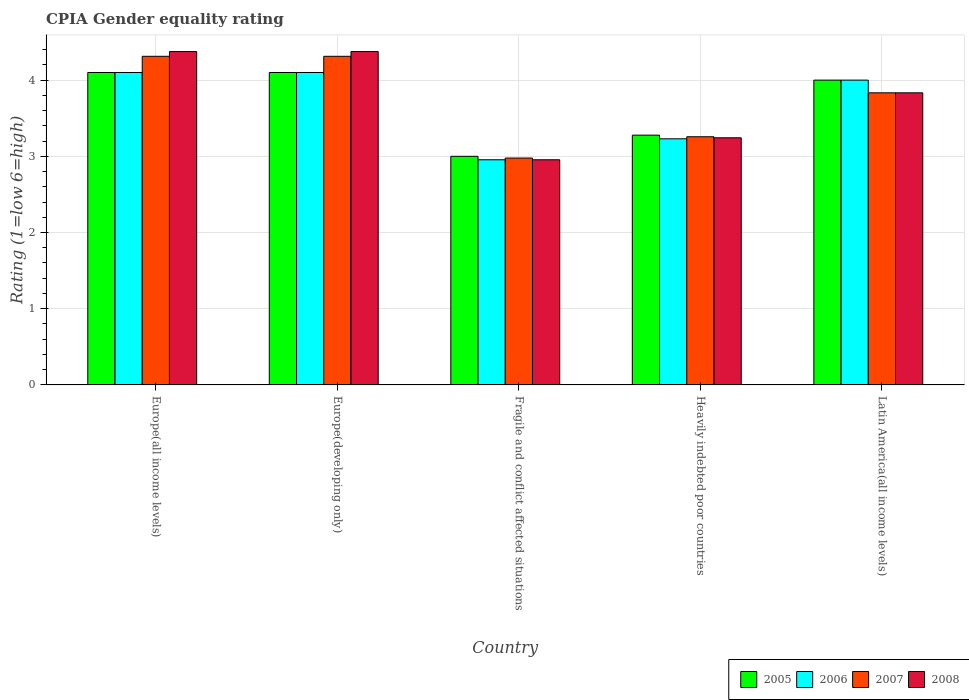How many different coloured bars are there?
Keep it short and to the point. 4. How many bars are there on the 1st tick from the left?
Offer a terse response. 4. What is the label of the 5th group of bars from the left?
Provide a succinct answer. Latin America(all income levels). In how many cases, is the number of bars for a given country not equal to the number of legend labels?
Your answer should be compact. 0. What is the CPIA rating in 2005 in Heavily indebted poor countries?
Your answer should be compact. 3.28. Across all countries, what is the maximum CPIA rating in 2008?
Make the answer very short. 4.38. Across all countries, what is the minimum CPIA rating in 2007?
Your answer should be very brief. 2.98. In which country was the CPIA rating in 2006 maximum?
Provide a succinct answer. Europe(all income levels). In which country was the CPIA rating in 2007 minimum?
Keep it short and to the point. Fragile and conflict affected situations. What is the total CPIA rating in 2007 in the graph?
Keep it short and to the point. 18.69. What is the difference between the CPIA rating in 2005 in Europe(developing only) and that in Fragile and conflict affected situations?
Your answer should be very brief. 1.1. What is the difference between the CPIA rating in 2006 in Europe(developing only) and the CPIA rating in 2007 in Fragile and conflict affected situations?
Your answer should be compact. 1.12. What is the average CPIA rating in 2006 per country?
Your response must be concise. 3.68. What is the difference between the CPIA rating of/in 2006 and CPIA rating of/in 2008 in Europe(all income levels)?
Offer a terse response. -0.28. What is the ratio of the CPIA rating in 2005 in Europe(all income levels) to that in Europe(developing only)?
Your answer should be compact. 1. Is the CPIA rating in 2007 in Europe(developing only) less than that in Fragile and conflict affected situations?
Make the answer very short. No. What is the difference between the highest and the second highest CPIA rating in 2006?
Keep it short and to the point. 0.1. What is the difference between the highest and the lowest CPIA rating in 2007?
Offer a very short reply. 1.34. In how many countries, is the CPIA rating in 2005 greater than the average CPIA rating in 2005 taken over all countries?
Offer a terse response. 3. What does the 1st bar from the left in Europe(developing only) represents?
Provide a short and direct response. 2005. What does the 2nd bar from the right in Fragile and conflict affected situations represents?
Your answer should be very brief. 2007. Is it the case that in every country, the sum of the CPIA rating in 2008 and CPIA rating in 2005 is greater than the CPIA rating in 2006?
Provide a succinct answer. Yes. How many bars are there?
Your answer should be very brief. 20. Are all the bars in the graph horizontal?
Make the answer very short. No. Does the graph contain any zero values?
Your answer should be compact. No. Where does the legend appear in the graph?
Make the answer very short. Bottom right. How are the legend labels stacked?
Your response must be concise. Horizontal. What is the title of the graph?
Your answer should be very brief. CPIA Gender equality rating. What is the label or title of the X-axis?
Offer a terse response. Country. What is the label or title of the Y-axis?
Give a very brief answer. Rating (1=low 6=high). What is the Rating (1=low 6=high) in 2005 in Europe(all income levels)?
Ensure brevity in your answer.  4.1. What is the Rating (1=low 6=high) of 2007 in Europe(all income levels)?
Provide a succinct answer. 4.31. What is the Rating (1=low 6=high) of 2008 in Europe(all income levels)?
Offer a very short reply. 4.38. What is the Rating (1=low 6=high) of 2007 in Europe(developing only)?
Give a very brief answer. 4.31. What is the Rating (1=low 6=high) in 2008 in Europe(developing only)?
Keep it short and to the point. 4.38. What is the Rating (1=low 6=high) of 2006 in Fragile and conflict affected situations?
Give a very brief answer. 2.95. What is the Rating (1=low 6=high) in 2007 in Fragile and conflict affected situations?
Offer a terse response. 2.98. What is the Rating (1=low 6=high) in 2008 in Fragile and conflict affected situations?
Keep it short and to the point. 2.95. What is the Rating (1=low 6=high) of 2005 in Heavily indebted poor countries?
Your answer should be very brief. 3.28. What is the Rating (1=low 6=high) in 2006 in Heavily indebted poor countries?
Give a very brief answer. 3.23. What is the Rating (1=low 6=high) in 2007 in Heavily indebted poor countries?
Ensure brevity in your answer.  3.26. What is the Rating (1=low 6=high) in 2008 in Heavily indebted poor countries?
Your answer should be compact. 3.24. What is the Rating (1=low 6=high) of 2005 in Latin America(all income levels)?
Provide a succinct answer. 4. What is the Rating (1=low 6=high) of 2006 in Latin America(all income levels)?
Ensure brevity in your answer.  4. What is the Rating (1=low 6=high) in 2007 in Latin America(all income levels)?
Offer a terse response. 3.83. What is the Rating (1=low 6=high) in 2008 in Latin America(all income levels)?
Keep it short and to the point. 3.83. Across all countries, what is the maximum Rating (1=low 6=high) of 2006?
Offer a terse response. 4.1. Across all countries, what is the maximum Rating (1=low 6=high) in 2007?
Offer a terse response. 4.31. Across all countries, what is the maximum Rating (1=low 6=high) in 2008?
Keep it short and to the point. 4.38. Across all countries, what is the minimum Rating (1=low 6=high) of 2006?
Offer a terse response. 2.95. Across all countries, what is the minimum Rating (1=low 6=high) of 2007?
Provide a short and direct response. 2.98. Across all countries, what is the minimum Rating (1=low 6=high) of 2008?
Your response must be concise. 2.95. What is the total Rating (1=low 6=high) in 2005 in the graph?
Make the answer very short. 18.48. What is the total Rating (1=low 6=high) in 2006 in the graph?
Make the answer very short. 18.38. What is the total Rating (1=low 6=high) in 2007 in the graph?
Make the answer very short. 18.69. What is the total Rating (1=low 6=high) of 2008 in the graph?
Offer a terse response. 18.78. What is the difference between the Rating (1=low 6=high) of 2007 in Europe(all income levels) and that in Europe(developing only)?
Your answer should be compact. 0. What is the difference between the Rating (1=low 6=high) in 2006 in Europe(all income levels) and that in Fragile and conflict affected situations?
Offer a terse response. 1.15. What is the difference between the Rating (1=low 6=high) in 2007 in Europe(all income levels) and that in Fragile and conflict affected situations?
Give a very brief answer. 1.34. What is the difference between the Rating (1=low 6=high) of 2008 in Europe(all income levels) and that in Fragile and conflict affected situations?
Provide a succinct answer. 1.42. What is the difference between the Rating (1=low 6=high) of 2005 in Europe(all income levels) and that in Heavily indebted poor countries?
Your answer should be very brief. 0.82. What is the difference between the Rating (1=low 6=high) of 2006 in Europe(all income levels) and that in Heavily indebted poor countries?
Your response must be concise. 0.87. What is the difference between the Rating (1=low 6=high) of 2007 in Europe(all income levels) and that in Heavily indebted poor countries?
Keep it short and to the point. 1.06. What is the difference between the Rating (1=low 6=high) of 2008 in Europe(all income levels) and that in Heavily indebted poor countries?
Your answer should be very brief. 1.13. What is the difference between the Rating (1=low 6=high) of 2005 in Europe(all income levels) and that in Latin America(all income levels)?
Provide a short and direct response. 0.1. What is the difference between the Rating (1=low 6=high) of 2006 in Europe(all income levels) and that in Latin America(all income levels)?
Give a very brief answer. 0.1. What is the difference between the Rating (1=low 6=high) of 2007 in Europe(all income levels) and that in Latin America(all income levels)?
Give a very brief answer. 0.48. What is the difference between the Rating (1=low 6=high) of 2008 in Europe(all income levels) and that in Latin America(all income levels)?
Ensure brevity in your answer.  0.54. What is the difference between the Rating (1=low 6=high) of 2006 in Europe(developing only) and that in Fragile and conflict affected situations?
Make the answer very short. 1.15. What is the difference between the Rating (1=low 6=high) of 2007 in Europe(developing only) and that in Fragile and conflict affected situations?
Keep it short and to the point. 1.34. What is the difference between the Rating (1=low 6=high) of 2008 in Europe(developing only) and that in Fragile and conflict affected situations?
Offer a very short reply. 1.42. What is the difference between the Rating (1=low 6=high) of 2005 in Europe(developing only) and that in Heavily indebted poor countries?
Your answer should be very brief. 0.82. What is the difference between the Rating (1=low 6=high) of 2006 in Europe(developing only) and that in Heavily indebted poor countries?
Provide a short and direct response. 0.87. What is the difference between the Rating (1=low 6=high) of 2007 in Europe(developing only) and that in Heavily indebted poor countries?
Offer a terse response. 1.06. What is the difference between the Rating (1=low 6=high) of 2008 in Europe(developing only) and that in Heavily indebted poor countries?
Ensure brevity in your answer.  1.13. What is the difference between the Rating (1=low 6=high) of 2007 in Europe(developing only) and that in Latin America(all income levels)?
Keep it short and to the point. 0.48. What is the difference between the Rating (1=low 6=high) of 2008 in Europe(developing only) and that in Latin America(all income levels)?
Keep it short and to the point. 0.54. What is the difference between the Rating (1=low 6=high) of 2005 in Fragile and conflict affected situations and that in Heavily indebted poor countries?
Give a very brief answer. -0.28. What is the difference between the Rating (1=low 6=high) in 2006 in Fragile and conflict affected situations and that in Heavily indebted poor countries?
Your answer should be compact. -0.28. What is the difference between the Rating (1=low 6=high) in 2007 in Fragile and conflict affected situations and that in Heavily indebted poor countries?
Your answer should be very brief. -0.28. What is the difference between the Rating (1=low 6=high) of 2008 in Fragile and conflict affected situations and that in Heavily indebted poor countries?
Provide a short and direct response. -0.29. What is the difference between the Rating (1=low 6=high) of 2006 in Fragile and conflict affected situations and that in Latin America(all income levels)?
Ensure brevity in your answer.  -1.05. What is the difference between the Rating (1=low 6=high) of 2007 in Fragile and conflict affected situations and that in Latin America(all income levels)?
Offer a terse response. -0.86. What is the difference between the Rating (1=low 6=high) of 2008 in Fragile and conflict affected situations and that in Latin America(all income levels)?
Offer a terse response. -0.88. What is the difference between the Rating (1=low 6=high) in 2005 in Heavily indebted poor countries and that in Latin America(all income levels)?
Make the answer very short. -0.72. What is the difference between the Rating (1=low 6=high) of 2006 in Heavily indebted poor countries and that in Latin America(all income levels)?
Your answer should be compact. -0.77. What is the difference between the Rating (1=low 6=high) of 2007 in Heavily indebted poor countries and that in Latin America(all income levels)?
Make the answer very short. -0.58. What is the difference between the Rating (1=low 6=high) in 2008 in Heavily indebted poor countries and that in Latin America(all income levels)?
Your response must be concise. -0.59. What is the difference between the Rating (1=low 6=high) in 2005 in Europe(all income levels) and the Rating (1=low 6=high) in 2006 in Europe(developing only)?
Ensure brevity in your answer.  0. What is the difference between the Rating (1=low 6=high) in 2005 in Europe(all income levels) and the Rating (1=low 6=high) in 2007 in Europe(developing only)?
Provide a succinct answer. -0.21. What is the difference between the Rating (1=low 6=high) in 2005 in Europe(all income levels) and the Rating (1=low 6=high) in 2008 in Europe(developing only)?
Give a very brief answer. -0.28. What is the difference between the Rating (1=low 6=high) in 2006 in Europe(all income levels) and the Rating (1=low 6=high) in 2007 in Europe(developing only)?
Offer a terse response. -0.21. What is the difference between the Rating (1=low 6=high) of 2006 in Europe(all income levels) and the Rating (1=low 6=high) of 2008 in Europe(developing only)?
Offer a very short reply. -0.28. What is the difference between the Rating (1=low 6=high) in 2007 in Europe(all income levels) and the Rating (1=low 6=high) in 2008 in Europe(developing only)?
Keep it short and to the point. -0.06. What is the difference between the Rating (1=low 6=high) of 2005 in Europe(all income levels) and the Rating (1=low 6=high) of 2006 in Fragile and conflict affected situations?
Your answer should be compact. 1.15. What is the difference between the Rating (1=low 6=high) in 2005 in Europe(all income levels) and the Rating (1=low 6=high) in 2007 in Fragile and conflict affected situations?
Provide a succinct answer. 1.12. What is the difference between the Rating (1=low 6=high) in 2005 in Europe(all income levels) and the Rating (1=low 6=high) in 2008 in Fragile and conflict affected situations?
Offer a very short reply. 1.15. What is the difference between the Rating (1=low 6=high) in 2006 in Europe(all income levels) and the Rating (1=low 6=high) in 2007 in Fragile and conflict affected situations?
Your response must be concise. 1.12. What is the difference between the Rating (1=low 6=high) of 2006 in Europe(all income levels) and the Rating (1=low 6=high) of 2008 in Fragile and conflict affected situations?
Keep it short and to the point. 1.15. What is the difference between the Rating (1=low 6=high) of 2007 in Europe(all income levels) and the Rating (1=low 6=high) of 2008 in Fragile and conflict affected situations?
Provide a succinct answer. 1.36. What is the difference between the Rating (1=low 6=high) of 2005 in Europe(all income levels) and the Rating (1=low 6=high) of 2006 in Heavily indebted poor countries?
Provide a succinct answer. 0.87. What is the difference between the Rating (1=low 6=high) of 2005 in Europe(all income levels) and the Rating (1=low 6=high) of 2007 in Heavily indebted poor countries?
Offer a terse response. 0.84. What is the difference between the Rating (1=low 6=high) of 2005 in Europe(all income levels) and the Rating (1=low 6=high) of 2008 in Heavily indebted poor countries?
Give a very brief answer. 0.86. What is the difference between the Rating (1=low 6=high) in 2006 in Europe(all income levels) and the Rating (1=low 6=high) in 2007 in Heavily indebted poor countries?
Your answer should be compact. 0.84. What is the difference between the Rating (1=low 6=high) of 2006 in Europe(all income levels) and the Rating (1=low 6=high) of 2008 in Heavily indebted poor countries?
Offer a terse response. 0.86. What is the difference between the Rating (1=low 6=high) in 2007 in Europe(all income levels) and the Rating (1=low 6=high) in 2008 in Heavily indebted poor countries?
Offer a very short reply. 1.07. What is the difference between the Rating (1=low 6=high) of 2005 in Europe(all income levels) and the Rating (1=low 6=high) of 2006 in Latin America(all income levels)?
Make the answer very short. 0.1. What is the difference between the Rating (1=low 6=high) of 2005 in Europe(all income levels) and the Rating (1=low 6=high) of 2007 in Latin America(all income levels)?
Provide a succinct answer. 0.27. What is the difference between the Rating (1=low 6=high) of 2005 in Europe(all income levels) and the Rating (1=low 6=high) of 2008 in Latin America(all income levels)?
Offer a terse response. 0.27. What is the difference between the Rating (1=low 6=high) in 2006 in Europe(all income levels) and the Rating (1=low 6=high) in 2007 in Latin America(all income levels)?
Make the answer very short. 0.27. What is the difference between the Rating (1=low 6=high) in 2006 in Europe(all income levels) and the Rating (1=low 6=high) in 2008 in Latin America(all income levels)?
Your response must be concise. 0.27. What is the difference between the Rating (1=low 6=high) in 2007 in Europe(all income levels) and the Rating (1=low 6=high) in 2008 in Latin America(all income levels)?
Ensure brevity in your answer.  0.48. What is the difference between the Rating (1=low 6=high) in 2005 in Europe(developing only) and the Rating (1=low 6=high) in 2006 in Fragile and conflict affected situations?
Provide a succinct answer. 1.15. What is the difference between the Rating (1=low 6=high) in 2005 in Europe(developing only) and the Rating (1=low 6=high) in 2007 in Fragile and conflict affected situations?
Offer a terse response. 1.12. What is the difference between the Rating (1=low 6=high) in 2005 in Europe(developing only) and the Rating (1=low 6=high) in 2008 in Fragile and conflict affected situations?
Offer a terse response. 1.15. What is the difference between the Rating (1=low 6=high) of 2006 in Europe(developing only) and the Rating (1=low 6=high) of 2007 in Fragile and conflict affected situations?
Offer a terse response. 1.12. What is the difference between the Rating (1=low 6=high) of 2006 in Europe(developing only) and the Rating (1=low 6=high) of 2008 in Fragile and conflict affected situations?
Your response must be concise. 1.15. What is the difference between the Rating (1=low 6=high) of 2007 in Europe(developing only) and the Rating (1=low 6=high) of 2008 in Fragile and conflict affected situations?
Give a very brief answer. 1.36. What is the difference between the Rating (1=low 6=high) of 2005 in Europe(developing only) and the Rating (1=low 6=high) of 2006 in Heavily indebted poor countries?
Offer a very short reply. 0.87. What is the difference between the Rating (1=low 6=high) in 2005 in Europe(developing only) and the Rating (1=low 6=high) in 2007 in Heavily indebted poor countries?
Give a very brief answer. 0.84. What is the difference between the Rating (1=low 6=high) in 2005 in Europe(developing only) and the Rating (1=low 6=high) in 2008 in Heavily indebted poor countries?
Provide a short and direct response. 0.86. What is the difference between the Rating (1=low 6=high) of 2006 in Europe(developing only) and the Rating (1=low 6=high) of 2007 in Heavily indebted poor countries?
Your answer should be very brief. 0.84. What is the difference between the Rating (1=low 6=high) of 2006 in Europe(developing only) and the Rating (1=low 6=high) of 2008 in Heavily indebted poor countries?
Your answer should be very brief. 0.86. What is the difference between the Rating (1=low 6=high) of 2007 in Europe(developing only) and the Rating (1=low 6=high) of 2008 in Heavily indebted poor countries?
Offer a terse response. 1.07. What is the difference between the Rating (1=low 6=high) in 2005 in Europe(developing only) and the Rating (1=low 6=high) in 2007 in Latin America(all income levels)?
Your response must be concise. 0.27. What is the difference between the Rating (1=low 6=high) of 2005 in Europe(developing only) and the Rating (1=low 6=high) of 2008 in Latin America(all income levels)?
Ensure brevity in your answer.  0.27. What is the difference between the Rating (1=low 6=high) in 2006 in Europe(developing only) and the Rating (1=low 6=high) in 2007 in Latin America(all income levels)?
Provide a succinct answer. 0.27. What is the difference between the Rating (1=low 6=high) of 2006 in Europe(developing only) and the Rating (1=low 6=high) of 2008 in Latin America(all income levels)?
Offer a terse response. 0.27. What is the difference between the Rating (1=low 6=high) of 2007 in Europe(developing only) and the Rating (1=low 6=high) of 2008 in Latin America(all income levels)?
Keep it short and to the point. 0.48. What is the difference between the Rating (1=low 6=high) in 2005 in Fragile and conflict affected situations and the Rating (1=low 6=high) in 2006 in Heavily indebted poor countries?
Your answer should be very brief. -0.23. What is the difference between the Rating (1=low 6=high) in 2005 in Fragile and conflict affected situations and the Rating (1=low 6=high) in 2007 in Heavily indebted poor countries?
Give a very brief answer. -0.26. What is the difference between the Rating (1=low 6=high) of 2005 in Fragile and conflict affected situations and the Rating (1=low 6=high) of 2008 in Heavily indebted poor countries?
Provide a succinct answer. -0.24. What is the difference between the Rating (1=low 6=high) in 2006 in Fragile and conflict affected situations and the Rating (1=low 6=high) in 2007 in Heavily indebted poor countries?
Ensure brevity in your answer.  -0.3. What is the difference between the Rating (1=low 6=high) in 2006 in Fragile and conflict affected situations and the Rating (1=low 6=high) in 2008 in Heavily indebted poor countries?
Your answer should be compact. -0.29. What is the difference between the Rating (1=low 6=high) in 2007 in Fragile and conflict affected situations and the Rating (1=low 6=high) in 2008 in Heavily indebted poor countries?
Provide a short and direct response. -0.27. What is the difference between the Rating (1=low 6=high) of 2005 in Fragile and conflict affected situations and the Rating (1=low 6=high) of 2006 in Latin America(all income levels)?
Offer a terse response. -1. What is the difference between the Rating (1=low 6=high) of 2005 in Fragile and conflict affected situations and the Rating (1=low 6=high) of 2007 in Latin America(all income levels)?
Ensure brevity in your answer.  -0.83. What is the difference between the Rating (1=low 6=high) in 2006 in Fragile and conflict affected situations and the Rating (1=low 6=high) in 2007 in Latin America(all income levels)?
Offer a terse response. -0.88. What is the difference between the Rating (1=low 6=high) in 2006 in Fragile and conflict affected situations and the Rating (1=low 6=high) in 2008 in Latin America(all income levels)?
Give a very brief answer. -0.88. What is the difference between the Rating (1=low 6=high) of 2007 in Fragile and conflict affected situations and the Rating (1=low 6=high) of 2008 in Latin America(all income levels)?
Make the answer very short. -0.86. What is the difference between the Rating (1=low 6=high) in 2005 in Heavily indebted poor countries and the Rating (1=low 6=high) in 2006 in Latin America(all income levels)?
Offer a terse response. -0.72. What is the difference between the Rating (1=low 6=high) of 2005 in Heavily indebted poor countries and the Rating (1=low 6=high) of 2007 in Latin America(all income levels)?
Your answer should be compact. -0.56. What is the difference between the Rating (1=low 6=high) in 2005 in Heavily indebted poor countries and the Rating (1=low 6=high) in 2008 in Latin America(all income levels)?
Ensure brevity in your answer.  -0.56. What is the difference between the Rating (1=low 6=high) of 2006 in Heavily indebted poor countries and the Rating (1=low 6=high) of 2007 in Latin America(all income levels)?
Your response must be concise. -0.6. What is the difference between the Rating (1=low 6=high) of 2006 in Heavily indebted poor countries and the Rating (1=low 6=high) of 2008 in Latin America(all income levels)?
Your response must be concise. -0.6. What is the difference between the Rating (1=low 6=high) of 2007 in Heavily indebted poor countries and the Rating (1=low 6=high) of 2008 in Latin America(all income levels)?
Your answer should be compact. -0.58. What is the average Rating (1=low 6=high) in 2005 per country?
Make the answer very short. 3.7. What is the average Rating (1=low 6=high) of 2006 per country?
Provide a succinct answer. 3.68. What is the average Rating (1=low 6=high) in 2007 per country?
Keep it short and to the point. 3.74. What is the average Rating (1=low 6=high) of 2008 per country?
Ensure brevity in your answer.  3.76. What is the difference between the Rating (1=low 6=high) in 2005 and Rating (1=low 6=high) in 2007 in Europe(all income levels)?
Keep it short and to the point. -0.21. What is the difference between the Rating (1=low 6=high) in 2005 and Rating (1=low 6=high) in 2008 in Europe(all income levels)?
Offer a terse response. -0.28. What is the difference between the Rating (1=low 6=high) in 2006 and Rating (1=low 6=high) in 2007 in Europe(all income levels)?
Offer a terse response. -0.21. What is the difference between the Rating (1=low 6=high) in 2006 and Rating (1=low 6=high) in 2008 in Europe(all income levels)?
Your answer should be very brief. -0.28. What is the difference between the Rating (1=low 6=high) of 2007 and Rating (1=low 6=high) of 2008 in Europe(all income levels)?
Give a very brief answer. -0.06. What is the difference between the Rating (1=low 6=high) in 2005 and Rating (1=low 6=high) in 2006 in Europe(developing only)?
Offer a very short reply. 0. What is the difference between the Rating (1=low 6=high) of 2005 and Rating (1=low 6=high) of 2007 in Europe(developing only)?
Offer a very short reply. -0.21. What is the difference between the Rating (1=low 6=high) of 2005 and Rating (1=low 6=high) of 2008 in Europe(developing only)?
Offer a terse response. -0.28. What is the difference between the Rating (1=low 6=high) of 2006 and Rating (1=low 6=high) of 2007 in Europe(developing only)?
Your response must be concise. -0.21. What is the difference between the Rating (1=low 6=high) in 2006 and Rating (1=low 6=high) in 2008 in Europe(developing only)?
Your response must be concise. -0.28. What is the difference between the Rating (1=low 6=high) in 2007 and Rating (1=low 6=high) in 2008 in Europe(developing only)?
Ensure brevity in your answer.  -0.06. What is the difference between the Rating (1=low 6=high) in 2005 and Rating (1=low 6=high) in 2006 in Fragile and conflict affected situations?
Offer a very short reply. 0.05. What is the difference between the Rating (1=low 6=high) of 2005 and Rating (1=low 6=high) of 2007 in Fragile and conflict affected situations?
Your answer should be compact. 0.02. What is the difference between the Rating (1=low 6=high) of 2005 and Rating (1=low 6=high) of 2008 in Fragile and conflict affected situations?
Your answer should be compact. 0.05. What is the difference between the Rating (1=low 6=high) of 2006 and Rating (1=low 6=high) of 2007 in Fragile and conflict affected situations?
Make the answer very short. -0.02. What is the difference between the Rating (1=low 6=high) of 2006 and Rating (1=low 6=high) of 2008 in Fragile and conflict affected situations?
Your response must be concise. 0. What is the difference between the Rating (1=low 6=high) in 2007 and Rating (1=low 6=high) in 2008 in Fragile and conflict affected situations?
Offer a very short reply. 0.02. What is the difference between the Rating (1=low 6=high) of 2005 and Rating (1=low 6=high) of 2006 in Heavily indebted poor countries?
Keep it short and to the point. 0.05. What is the difference between the Rating (1=low 6=high) of 2005 and Rating (1=low 6=high) of 2007 in Heavily indebted poor countries?
Keep it short and to the point. 0.02. What is the difference between the Rating (1=low 6=high) in 2005 and Rating (1=low 6=high) in 2008 in Heavily indebted poor countries?
Your response must be concise. 0.03. What is the difference between the Rating (1=low 6=high) in 2006 and Rating (1=low 6=high) in 2007 in Heavily indebted poor countries?
Keep it short and to the point. -0.03. What is the difference between the Rating (1=low 6=high) of 2006 and Rating (1=low 6=high) of 2008 in Heavily indebted poor countries?
Offer a terse response. -0.01. What is the difference between the Rating (1=low 6=high) in 2007 and Rating (1=low 6=high) in 2008 in Heavily indebted poor countries?
Make the answer very short. 0.01. What is the difference between the Rating (1=low 6=high) of 2005 and Rating (1=low 6=high) of 2007 in Latin America(all income levels)?
Provide a short and direct response. 0.17. What is the difference between the Rating (1=low 6=high) in 2005 and Rating (1=low 6=high) in 2008 in Latin America(all income levels)?
Provide a succinct answer. 0.17. What is the difference between the Rating (1=low 6=high) in 2006 and Rating (1=low 6=high) in 2007 in Latin America(all income levels)?
Give a very brief answer. 0.17. What is the ratio of the Rating (1=low 6=high) of 2006 in Europe(all income levels) to that in Europe(developing only)?
Make the answer very short. 1. What is the ratio of the Rating (1=low 6=high) in 2005 in Europe(all income levels) to that in Fragile and conflict affected situations?
Ensure brevity in your answer.  1.37. What is the ratio of the Rating (1=low 6=high) of 2006 in Europe(all income levels) to that in Fragile and conflict affected situations?
Your answer should be compact. 1.39. What is the ratio of the Rating (1=low 6=high) in 2007 in Europe(all income levels) to that in Fragile and conflict affected situations?
Your answer should be very brief. 1.45. What is the ratio of the Rating (1=low 6=high) of 2008 in Europe(all income levels) to that in Fragile and conflict affected situations?
Ensure brevity in your answer.  1.48. What is the ratio of the Rating (1=low 6=high) of 2005 in Europe(all income levels) to that in Heavily indebted poor countries?
Your answer should be very brief. 1.25. What is the ratio of the Rating (1=low 6=high) in 2006 in Europe(all income levels) to that in Heavily indebted poor countries?
Keep it short and to the point. 1.27. What is the ratio of the Rating (1=low 6=high) of 2007 in Europe(all income levels) to that in Heavily indebted poor countries?
Your answer should be very brief. 1.32. What is the ratio of the Rating (1=low 6=high) of 2008 in Europe(all income levels) to that in Heavily indebted poor countries?
Keep it short and to the point. 1.35. What is the ratio of the Rating (1=low 6=high) of 2007 in Europe(all income levels) to that in Latin America(all income levels)?
Keep it short and to the point. 1.12. What is the ratio of the Rating (1=low 6=high) in 2008 in Europe(all income levels) to that in Latin America(all income levels)?
Your response must be concise. 1.14. What is the ratio of the Rating (1=low 6=high) of 2005 in Europe(developing only) to that in Fragile and conflict affected situations?
Provide a succinct answer. 1.37. What is the ratio of the Rating (1=low 6=high) of 2006 in Europe(developing only) to that in Fragile and conflict affected situations?
Your response must be concise. 1.39. What is the ratio of the Rating (1=low 6=high) in 2007 in Europe(developing only) to that in Fragile and conflict affected situations?
Make the answer very short. 1.45. What is the ratio of the Rating (1=low 6=high) in 2008 in Europe(developing only) to that in Fragile and conflict affected situations?
Provide a succinct answer. 1.48. What is the ratio of the Rating (1=low 6=high) of 2005 in Europe(developing only) to that in Heavily indebted poor countries?
Provide a short and direct response. 1.25. What is the ratio of the Rating (1=low 6=high) of 2006 in Europe(developing only) to that in Heavily indebted poor countries?
Offer a terse response. 1.27. What is the ratio of the Rating (1=low 6=high) in 2007 in Europe(developing only) to that in Heavily indebted poor countries?
Give a very brief answer. 1.32. What is the ratio of the Rating (1=low 6=high) of 2008 in Europe(developing only) to that in Heavily indebted poor countries?
Offer a terse response. 1.35. What is the ratio of the Rating (1=low 6=high) of 2005 in Europe(developing only) to that in Latin America(all income levels)?
Provide a short and direct response. 1.02. What is the ratio of the Rating (1=low 6=high) in 2008 in Europe(developing only) to that in Latin America(all income levels)?
Your response must be concise. 1.14. What is the ratio of the Rating (1=low 6=high) of 2005 in Fragile and conflict affected situations to that in Heavily indebted poor countries?
Provide a succinct answer. 0.92. What is the ratio of the Rating (1=low 6=high) in 2006 in Fragile and conflict affected situations to that in Heavily indebted poor countries?
Offer a terse response. 0.91. What is the ratio of the Rating (1=low 6=high) of 2007 in Fragile and conflict affected situations to that in Heavily indebted poor countries?
Keep it short and to the point. 0.91. What is the ratio of the Rating (1=low 6=high) in 2008 in Fragile and conflict affected situations to that in Heavily indebted poor countries?
Your answer should be compact. 0.91. What is the ratio of the Rating (1=low 6=high) in 2005 in Fragile and conflict affected situations to that in Latin America(all income levels)?
Your response must be concise. 0.75. What is the ratio of the Rating (1=low 6=high) in 2006 in Fragile and conflict affected situations to that in Latin America(all income levels)?
Provide a short and direct response. 0.74. What is the ratio of the Rating (1=low 6=high) in 2007 in Fragile and conflict affected situations to that in Latin America(all income levels)?
Offer a very short reply. 0.78. What is the ratio of the Rating (1=low 6=high) in 2008 in Fragile and conflict affected situations to that in Latin America(all income levels)?
Offer a terse response. 0.77. What is the ratio of the Rating (1=low 6=high) of 2005 in Heavily indebted poor countries to that in Latin America(all income levels)?
Your answer should be very brief. 0.82. What is the ratio of the Rating (1=low 6=high) in 2006 in Heavily indebted poor countries to that in Latin America(all income levels)?
Offer a terse response. 0.81. What is the ratio of the Rating (1=low 6=high) of 2007 in Heavily indebted poor countries to that in Latin America(all income levels)?
Keep it short and to the point. 0.85. What is the ratio of the Rating (1=low 6=high) in 2008 in Heavily indebted poor countries to that in Latin America(all income levels)?
Ensure brevity in your answer.  0.85. What is the difference between the highest and the second highest Rating (1=low 6=high) in 2005?
Offer a terse response. 0. What is the difference between the highest and the second highest Rating (1=low 6=high) of 2007?
Ensure brevity in your answer.  0. What is the difference between the highest and the second highest Rating (1=low 6=high) in 2008?
Offer a very short reply. 0. What is the difference between the highest and the lowest Rating (1=low 6=high) in 2005?
Keep it short and to the point. 1.1. What is the difference between the highest and the lowest Rating (1=low 6=high) of 2006?
Keep it short and to the point. 1.15. What is the difference between the highest and the lowest Rating (1=low 6=high) in 2007?
Give a very brief answer. 1.34. What is the difference between the highest and the lowest Rating (1=low 6=high) of 2008?
Offer a very short reply. 1.42. 